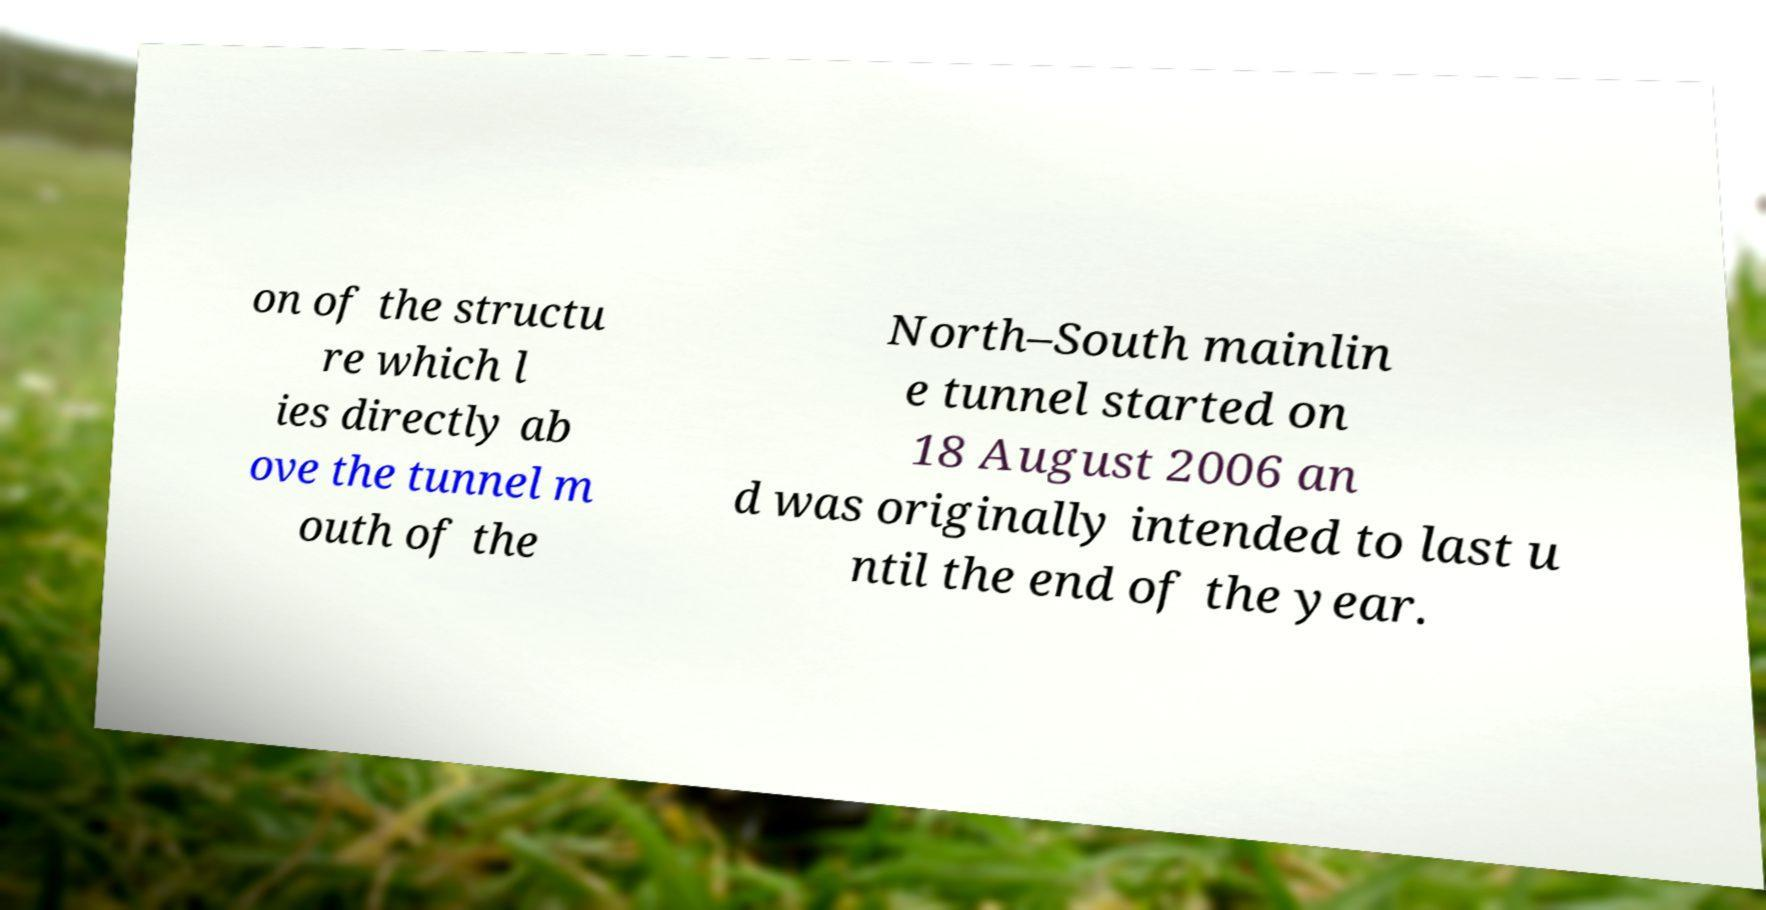There's text embedded in this image that I need extracted. Can you transcribe it verbatim? on of the structu re which l ies directly ab ove the tunnel m outh of the North–South mainlin e tunnel started on 18 August 2006 an d was originally intended to last u ntil the end of the year. 